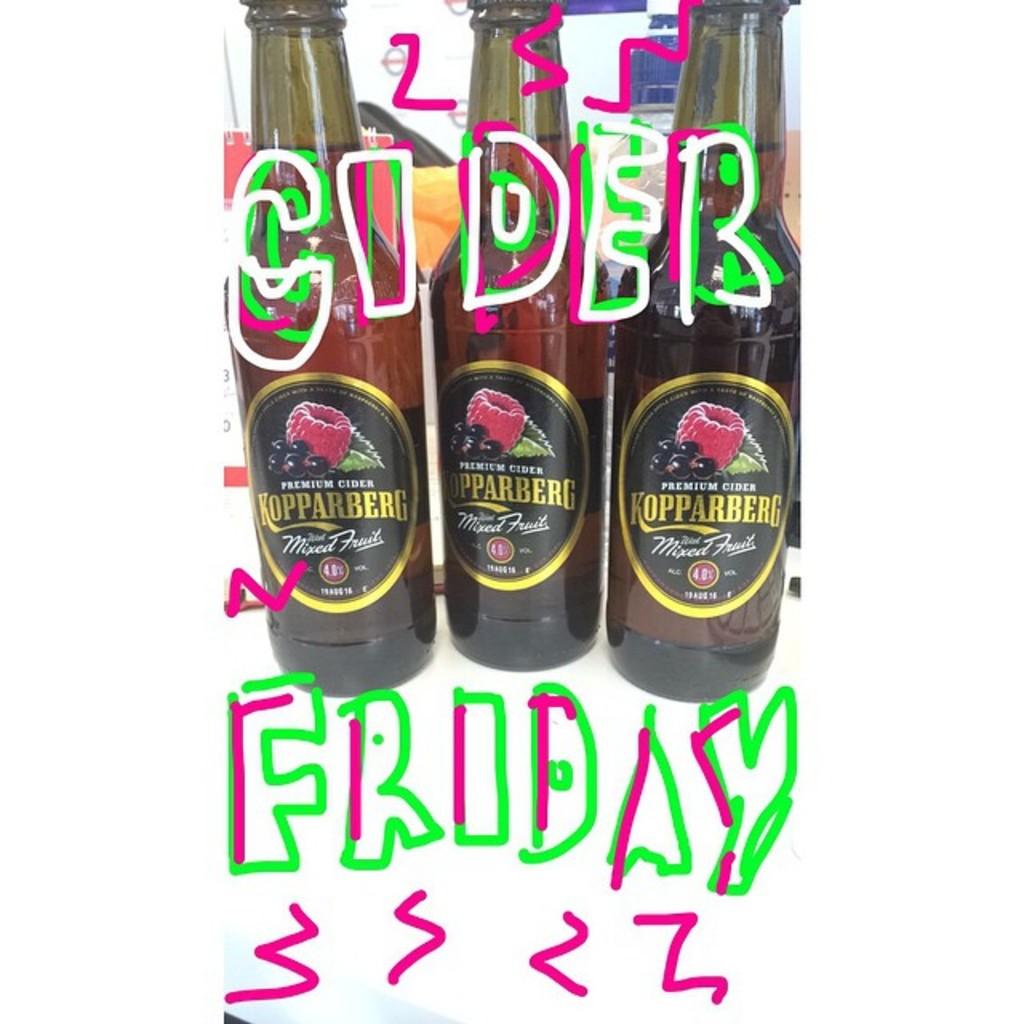Where can i purchase this cider?
Ensure brevity in your answer.  Unanswerable. 